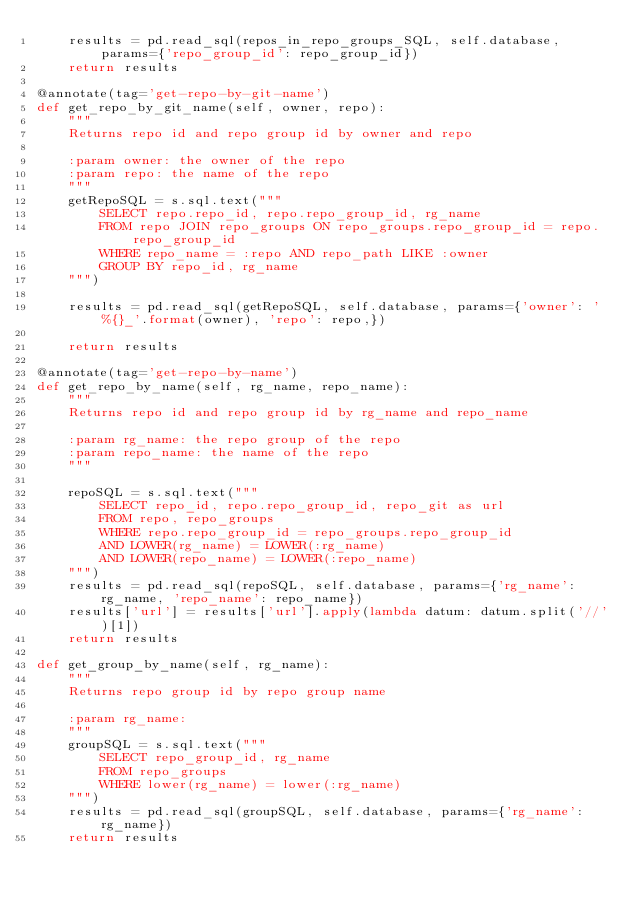<code> <loc_0><loc_0><loc_500><loc_500><_Python_>    results = pd.read_sql(repos_in_repo_groups_SQL, self.database, params={'repo_group_id': repo_group_id})
    return results

@annotate(tag='get-repo-by-git-name')
def get_repo_by_git_name(self, owner, repo):
    """
    Returns repo id and repo group id by owner and repo

    :param owner: the owner of the repo
    :param repo: the name of the repo
    """
    getRepoSQL = s.sql.text("""
        SELECT repo.repo_id, repo.repo_group_id, rg_name
        FROM repo JOIN repo_groups ON repo_groups.repo_group_id = repo.repo_group_id
        WHERE repo_name = :repo AND repo_path LIKE :owner
        GROUP BY repo_id, rg_name
    """)

    results = pd.read_sql(getRepoSQL, self.database, params={'owner': '%{}_'.format(owner), 'repo': repo,})

    return results

@annotate(tag='get-repo-by-name')
def get_repo_by_name(self, rg_name, repo_name):
    """
    Returns repo id and repo group id by rg_name and repo_name

    :param rg_name: the repo group of the repo
    :param repo_name: the name of the repo
    """

    repoSQL = s.sql.text("""
        SELECT repo_id, repo.repo_group_id, repo_git as url
        FROM repo, repo_groups
        WHERE repo.repo_group_id = repo_groups.repo_group_id
        AND LOWER(rg_name) = LOWER(:rg_name)
        AND LOWER(repo_name) = LOWER(:repo_name)
    """)
    results = pd.read_sql(repoSQL, self.database, params={'rg_name': rg_name, 'repo_name': repo_name})
    results['url'] = results['url'].apply(lambda datum: datum.split('//')[1])
    return results

def get_group_by_name(self, rg_name):
    """
    Returns repo group id by repo group name

    :param rg_name:
    """
    groupSQL = s.sql.text("""
        SELECT repo_group_id, rg_name
        FROM repo_groups
        WHERE lower(rg_name) = lower(:rg_name)
    """)
    results = pd.read_sql(groupSQL, self.database, params={'rg_name': rg_name})
    return results
</code> 